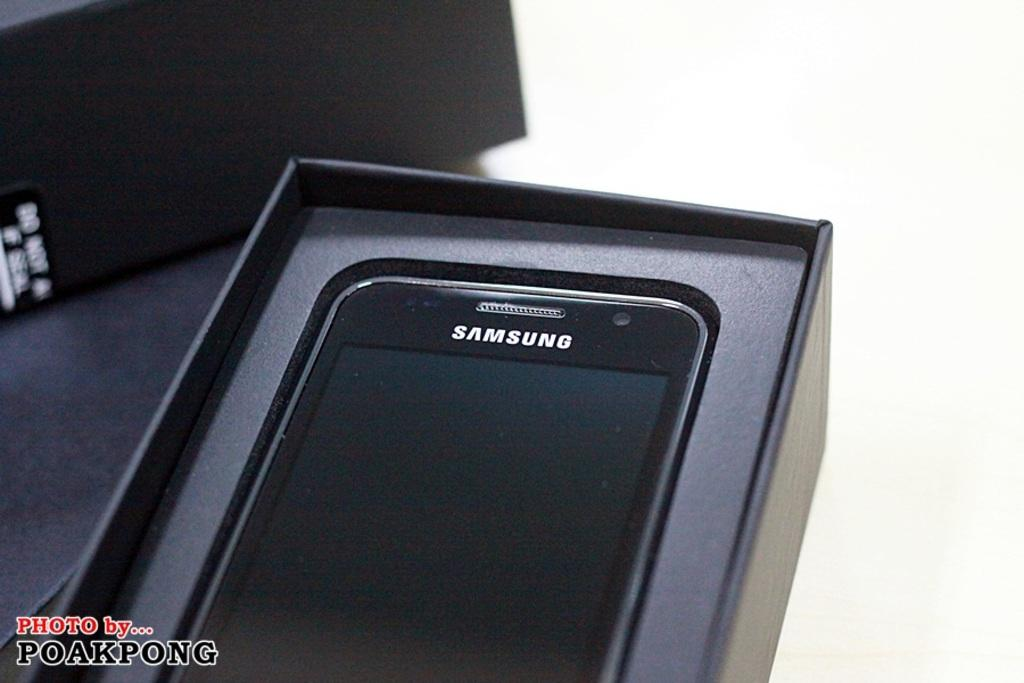<image>
Render a clear and concise summary of the photo. A black Samsung smartphone in the opened packaging. 